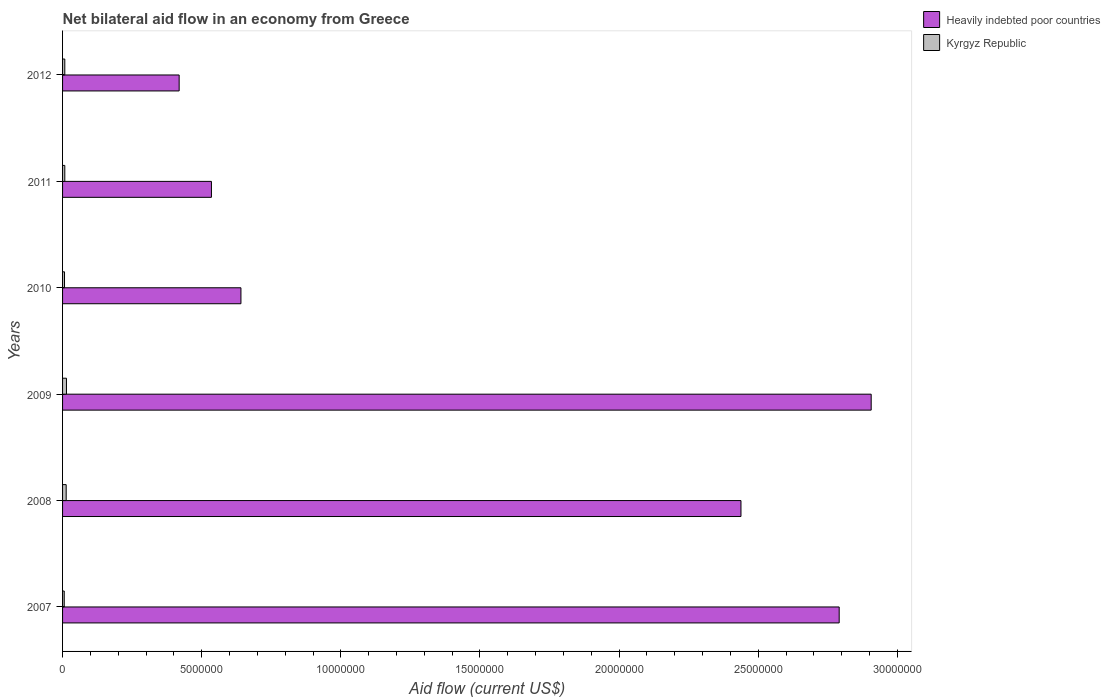How many groups of bars are there?
Ensure brevity in your answer.  6. Are the number of bars on each tick of the Y-axis equal?
Keep it short and to the point. Yes. How many bars are there on the 6th tick from the bottom?
Your answer should be compact. 2. Across all years, what is the maximum net bilateral aid flow in Heavily indebted poor countries?
Offer a terse response. 2.91e+07. Across all years, what is the minimum net bilateral aid flow in Heavily indebted poor countries?
Ensure brevity in your answer.  4.19e+06. What is the total net bilateral aid flow in Heavily indebted poor countries in the graph?
Offer a very short reply. 9.73e+07. What is the difference between the net bilateral aid flow in Heavily indebted poor countries in 2010 and the net bilateral aid flow in Kyrgyz Republic in 2009?
Ensure brevity in your answer.  6.27e+06. What is the average net bilateral aid flow in Kyrgyz Republic per year?
Your answer should be very brief. 9.33e+04. In the year 2012, what is the difference between the net bilateral aid flow in Heavily indebted poor countries and net bilateral aid flow in Kyrgyz Republic?
Your response must be concise. 4.11e+06. What is the ratio of the net bilateral aid flow in Heavily indebted poor countries in 2007 to that in 2008?
Offer a terse response. 1.14. Is the net bilateral aid flow in Heavily indebted poor countries in 2009 less than that in 2011?
Make the answer very short. No. Is the difference between the net bilateral aid flow in Heavily indebted poor countries in 2007 and 2012 greater than the difference between the net bilateral aid flow in Kyrgyz Republic in 2007 and 2012?
Make the answer very short. Yes. What is the difference between the highest and the second highest net bilateral aid flow in Heavily indebted poor countries?
Provide a short and direct response. 1.15e+06. What is the difference between the highest and the lowest net bilateral aid flow in Kyrgyz Republic?
Offer a terse response. 8.00e+04. What does the 2nd bar from the top in 2007 represents?
Offer a very short reply. Heavily indebted poor countries. What does the 1st bar from the bottom in 2012 represents?
Provide a short and direct response. Heavily indebted poor countries. How many bars are there?
Your response must be concise. 12. Are all the bars in the graph horizontal?
Make the answer very short. Yes. How many legend labels are there?
Offer a terse response. 2. How are the legend labels stacked?
Your answer should be very brief. Vertical. What is the title of the graph?
Provide a succinct answer. Net bilateral aid flow in an economy from Greece. Does "Northern Mariana Islands" appear as one of the legend labels in the graph?
Keep it short and to the point. No. What is the label or title of the X-axis?
Give a very brief answer. Aid flow (current US$). What is the label or title of the Y-axis?
Your response must be concise. Years. What is the Aid flow (current US$) of Heavily indebted poor countries in 2007?
Make the answer very short. 2.79e+07. What is the Aid flow (current US$) in Heavily indebted poor countries in 2008?
Provide a short and direct response. 2.44e+07. What is the Aid flow (current US$) of Heavily indebted poor countries in 2009?
Your answer should be compact. 2.91e+07. What is the Aid flow (current US$) in Heavily indebted poor countries in 2010?
Provide a short and direct response. 6.41e+06. What is the Aid flow (current US$) of Kyrgyz Republic in 2010?
Provide a succinct answer. 7.00e+04. What is the Aid flow (current US$) in Heavily indebted poor countries in 2011?
Your response must be concise. 5.35e+06. What is the Aid flow (current US$) of Kyrgyz Republic in 2011?
Provide a short and direct response. 8.00e+04. What is the Aid flow (current US$) in Heavily indebted poor countries in 2012?
Your response must be concise. 4.19e+06. What is the Aid flow (current US$) of Kyrgyz Republic in 2012?
Your answer should be compact. 8.00e+04. Across all years, what is the maximum Aid flow (current US$) in Heavily indebted poor countries?
Provide a succinct answer. 2.91e+07. Across all years, what is the minimum Aid flow (current US$) in Heavily indebted poor countries?
Offer a terse response. 4.19e+06. Across all years, what is the minimum Aid flow (current US$) of Kyrgyz Republic?
Your answer should be very brief. 6.00e+04. What is the total Aid flow (current US$) of Heavily indebted poor countries in the graph?
Provide a short and direct response. 9.73e+07. What is the total Aid flow (current US$) in Kyrgyz Republic in the graph?
Make the answer very short. 5.60e+05. What is the difference between the Aid flow (current US$) of Heavily indebted poor countries in 2007 and that in 2008?
Your answer should be compact. 3.53e+06. What is the difference between the Aid flow (current US$) in Heavily indebted poor countries in 2007 and that in 2009?
Ensure brevity in your answer.  -1.15e+06. What is the difference between the Aid flow (current US$) of Heavily indebted poor countries in 2007 and that in 2010?
Provide a succinct answer. 2.15e+07. What is the difference between the Aid flow (current US$) in Heavily indebted poor countries in 2007 and that in 2011?
Ensure brevity in your answer.  2.26e+07. What is the difference between the Aid flow (current US$) in Heavily indebted poor countries in 2007 and that in 2012?
Keep it short and to the point. 2.37e+07. What is the difference between the Aid flow (current US$) of Kyrgyz Republic in 2007 and that in 2012?
Your response must be concise. -2.00e+04. What is the difference between the Aid flow (current US$) of Heavily indebted poor countries in 2008 and that in 2009?
Ensure brevity in your answer.  -4.68e+06. What is the difference between the Aid flow (current US$) in Kyrgyz Republic in 2008 and that in 2009?
Your response must be concise. -10000. What is the difference between the Aid flow (current US$) in Heavily indebted poor countries in 2008 and that in 2010?
Offer a terse response. 1.80e+07. What is the difference between the Aid flow (current US$) of Heavily indebted poor countries in 2008 and that in 2011?
Make the answer very short. 1.90e+07. What is the difference between the Aid flow (current US$) in Kyrgyz Republic in 2008 and that in 2011?
Offer a very short reply. 5.00e+04. What is the difference between the Aid flow (current US$) in Heavily indebted poor countries in 2008 and that in 2012?
Give a very brief answer. 2.02e+07. What is the difference between the Aid flow (current US$) of Heavily indebted poor countries in 2009 and that in 2010?
Offer a terse response. 2.26e+07. What is the difference between the Aid flow (current US$) in Kyrgyz Republic in 2009 and that in 2010?
Ensure brevity in your answer.  7.00e+04. What is the difference between the Aid flow (current US$) of Heavily indebted poor countries in 2009 and that in 2011?
Keep it short and to the point. 2.37e+07. What is the difference between the Aid flow (current US$) in Heavily indebted poor countries in 2009 and that in 2012?
Your response must be concise. 2.49e+07. What is the difference between the Aid flow (current US$) of Heavily indebted poor countries in 2010 and that in 2011?
Make the answer very short. 1.06e+06. What is the difference between the Aid flow (current US$) of Heavily indebted poor countries in 2010 and that in 2012?
Your response must be concise. 2.22e+06. What is the difference between the Aid flow (current US$) in Heavily indebted poor countries in 2011 and that in 2012?
Make the answer very short. 1.16e+06. What is the difference between the Aid flow (current US$) in Kyrgyz Republic in 2011 and that in 2012?
Your response must be concise. 0. What is the difference between the Aid flow (current US$) in Heavily indebted poor countries in 2007 and the Aid flow (current US$) in Kyrgyz Republic in 2008?
Offer a very short reply. 2.78e+07. What is the difference between the Aid flow (current US$) of Heavily indebted poor countries in 2007 and the Aid flow (current US$) of Kyrgyz Republic in 2009?
Keep it short and to the point. 2.78e+07. What is the difference between the Aid flow (current US$) in Heavily indebted poor countries in 2007 and the Aid flow (current US$) in Kyrgyz Republic in 2010?
Ensure brevity in your answer.  2.78e+07. What is the difference between the Aid flow (current US$) in Heavily indebted poor countries in 2007 and the Aid flow (current US$) in Kyrgyz Republic in 2011?
Provide a succinct answer. 2.78e+07. What is the difference between the Aid flow (current US$) of Heavily indebted poor countries in 2007 and the Aid flow (current US$) of Kyrgyz Republic in 2012?
Provide a succinct answer. 2.78e+07. What is the difference between the Aid flow (current US$) of Heavily indebted poor countries in 2008 and the Aid flow (current US$) of Kyrgyz Republic in 2009?
Provide a succinct answer. 2.42e+07. What is the difference between the Aid flow (current US$) in Heavily indebted poor countries in 2008 and the Aid flow (current US$) in Kyrgyz Republic in 2010?
Provide a short and direct response. 2.43e+07. What is the difference between the Aid flow (current US$) in Heavily indebted poor countries in 2008 and the Aid flow (current US$) in Kyrgyz Republic in 2011?
Ensure brevity in your answer.  2.43e+07. What is the difference between the Aid flow (current US$) of Heavily indebted poor countries in 2008 and the Aid flow (current US$) of Kyrgyz Republic in 2012?
Give a very brief answer. 2.43e+07. What is the difference between the Aid flow (current US$) of Heavily indebted poor countries in 2009 and the Aid flow (current US$) of Kyrgyz Republic in 2010?
Ensure brevity in your answer.  2.90e+07. What is the difference between the Aid flow (current US$) in Heavily indebted poor countries in 2009 and the Aid flow (current US$) in Kyrgyz Republic in 2011?
Provide a short and direct response. 2.90e+07. What is the difference between the Aid flow (current US$) of Heavily indebted poor countries in 2009 and the Aid flow (current US$) of Kyrgyz Republic in 2012?
Your response must be concise. 2.90e+07. What is the difference between the Aid flow (current US$) in Heavily indebted poor countries in 2010 and the Aid flow (current US$) in Kyrgyz Republic in 2011?
Keep it short and to the point. 6.33e+06. What is the difference between the Aid flow (current US$) of Heavily indebted poor countries in 2010 and the Aid flow (current US$) of Kyrgyz Republic in 2012?
Your response must be concise. 6.33e+06. What is the difference between the Aid flow (current US$) in Heavily indebted poor countries in 2011 and the Aid flow (current US$) in Kyrgyz Republic in 2012?
Ensure brevity in your answer.  5.27e+06. What is the average Aid flow (current US$) of Heavily indebted poor countries per year?
Keep it short and to the point. 1.62e+07. What is the average Aid flow (current US$) of Kyrgyz Republic per year?
Your answer should be very brief. 9.33e+04. In the year 2007, what is the difference between the Aid flow (current US$) in Heavily indebted poor countries and Aid flow (current US$) in Kyrgyz Republic?
Keep it short and to the point. 2.78e+07. In the year 2008, what is the difference between the Aid flow (current US$) of Heavily indebted poor countries and Aid flow (current US$) of Kyrgyz Republic?
Give a very brief answer. 2.42e+07. In the year 2009, what is the difference between the Aid flow (current US$) of Heavily indebted poor countries and Aid flow (current US$) of Kyrgyz Republic?
Your answer should be very brief. 2.89e+07. In the year 2010, what is the difference between the Aid flow (current US$) of Heavily indebted poor countries and Aid flow (current US$) of Kyrgyz Republic?
Keep it short and to the point. 6.34e+06. In the year 2011, what is the difference between the Aid flow (current US$) in Heavily indebted poor countries and Aid flow (current US$) in Kyrgyz Republic?
Make the answer very short. 5.27e+06. In the year 2012, what is the difference between the Aid flow (current US$) in Heavily indebted poor countries and Aid flow (current US$) in Kyrgyz Republic?
Provide a short and direct response. 4.11e+06. What is the ratio of the Aid flow (current US$) in Heavily indebted poor countries in 2007 to that in 2008?
Make the answer very short. 1.14. What is the ratio of the Aid flow (current US$) in Kyrgyz Republic in 2007 to that in 2008?
Provide a succinct answer. 0.46. What is the ratio of the Aid flow (current US$) in Heavily indebted poor countries in 2007 to that in 2009?
Give a very brief answer. 0.96. What is the ratio of the Aid flow (current US$) of Kyrgyz Republic in 2007 to that in 2009?
Keep it short and to the point. 0.43. What is the ratio of the Aid flow (current US$) in Heavily indebted poor countries in 2007 to that in 2010?
Make the answer very short. 4.35. What is the ratio of the Aid flow (current US$) of Heavily indebted poor countries in 2007 to that in 2011?
Your answer should be compact. 5.22. What is the ratio of the Aid flow (current US$) of Heavily indebted poor countries in 2007 to that in 2012?
Keep it short and to the point. 6.66. What is the ratio of the Aid flow (current US$) in Heavily indebted poor countries in 2008 to that in 2009?
Your answer should be very brief. 0.84. What is the ratio of the Aid flow (current US$) in Kyrgyz Republic in 2008 to that in 2009?
Your answer should be very brief. 0.93. What is the ratio of the Aid flow (current US$) of Heavily indebted poor countries in 2008 to that in 2010?
Offer a terse response. 3.8. What is the ratio of the Aid flow (current US$) in Kyrgyz Republic in 2008 to that in 2010?
Ensure brevity in your answer.  1.86. What is the ratio of the Aid flow (current US$) in Heavily indebted poor countries in 2008 to that in 2011?
Offer a terse response. 4.56. What is the ratio of the Aid flow (current US$) in Kyrgyz Republic in 2008 to that in 2011?
Give a very brief answer. 1.62. What is the ratio of the Aid flow (current US$) of Heavily indebted poor countries in 2008 to that in 2012?
Your answer should be very brief. 5.82. What is the ratio of the Aid flow (current US$) in Kyrgyz Republic in 2008 to that in 2012?
Your response must be concise. 1.62. What is the ratio of the Aid flow (current US$) in Heavily indebted poor countries in 2009 to that in 2010?
Provide a short and direct response. 4.53. What is the ratio of the Aid flow (current US$) in Heavily indebted poor countries in 2009 to that in 2011?
Give a very brief answer. 5.43. What is the ratio of the Aid flow (current US$) of Kyrgyz Republic in 2009 to that in 2011?
Your answer should be very brief. 1.75. What is the ratio of the Aid flow (current US$) of Heavily indebted poor countries in 2009 to that in 2012?
Make the answer very short. 6.94. What is the ratio of the Aid flow (current US$) in Heavily indebted poor countries in 2010 to that in 2011?
Offer a very short reply. 1.2. What is the ratio of the Aid flow (current US$) in Heavily indebted poor countries in 2010 to that in 2012?
Your answer should be compact. 1.53. What is the ratio of the Aid flow (current US$) of Heavily indebted poor countries in 2011 to that in 2012?
Give a very brief answer. 1.28. What is the ratio of the Aid flow (current US$) of Kyrgyz Republic in 2011 to that in 2012?
Provide a short and direct response. 1. What is the difference between the highest and the second highest Aid flow (current US$) in Heavily indebted poor countries?
Make the answer very short. 1.15e+06. What is the difference between the highest and the second highest Aid flow (current US$) of Kyrgyz Republic?
Offer a terse response. 10000. What is the difference between the highest and the lowest Aid flow (current US$) of Heavily indebted poor countries?
Offer a terse response. 2.49e+07. What is the difference between the highest and the lowest Aid flow (current US$) in Kyrgyz Republic?
Offer a very short reply. 8.00e+04. 